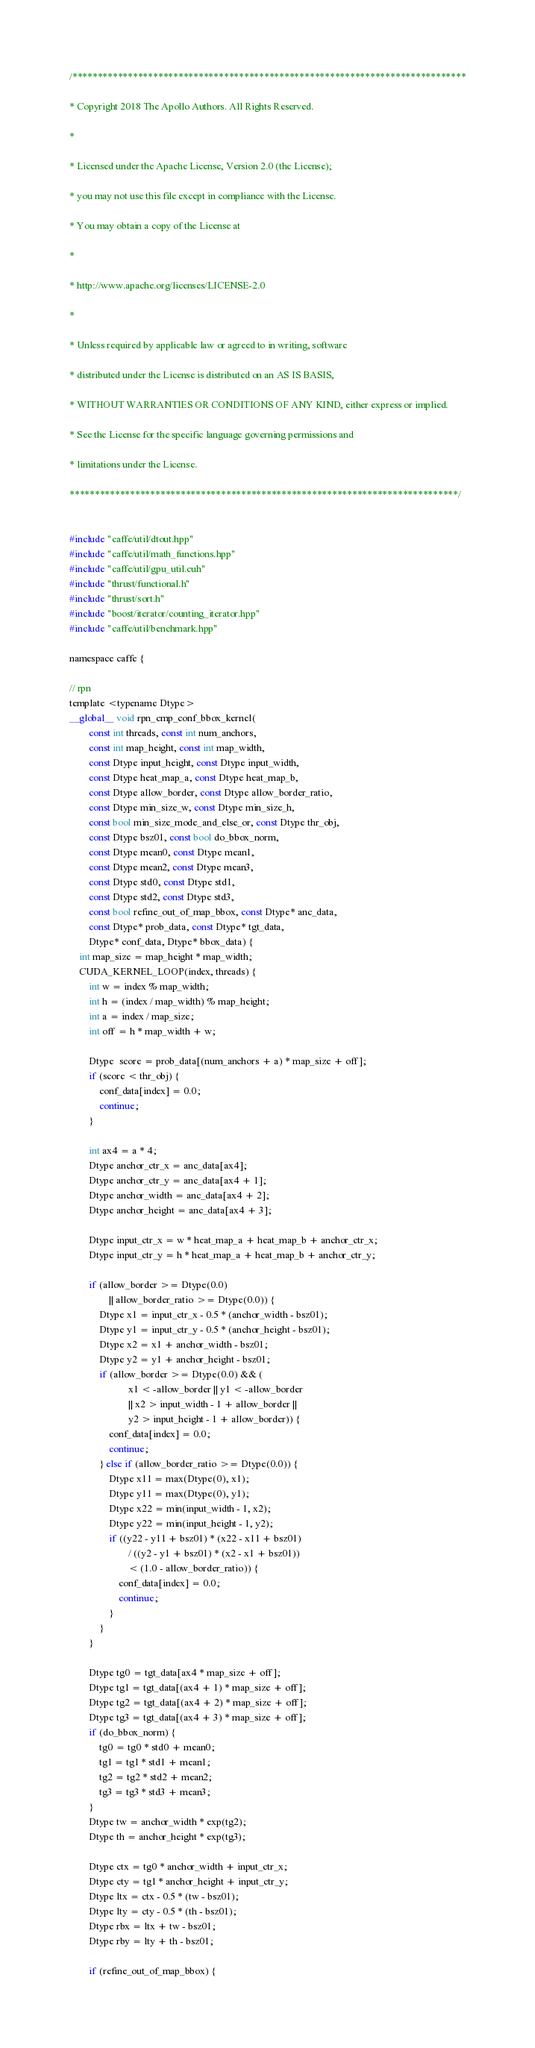Convert code to text. <code><loc_0><loc_0><loc_500><loc_500><_Cuda_>/******************************************************************************

* Copyright 2018 The Apollo Authors. All Rights Reserved.

*

* Licensed under the Apache License, Version 2.0 (the License);

* you may not use this file except in compliance with the License.

* You may obtain a copy of the License at

*

* http://www.apache.org/licenses/LICENSE-2.0

*

* Unless required by applicable law or agreed to in writing, software

* distributed under the License is distributed on an AS IS BASIS,

* WITHOUT WARRANTIES OR CONDITIONS OF ANY KIND, either express or implied.

* See the License for the specific language governing permissions and

* limitations under the License.

*****************************************************************************/


#include "caffe/util/dtout.hpp"
#include "caffe/util/math_functions.hpp"
#include "caffe/util/gpu_util.cuh"
#include "thrust/functional.h"
#include "thrust/sort.h"
#include "boost/iterator/counting_iterator.hpp"
#include "caffe/util/benchmark.hpp"

namespace caffe {

// rpn
template <typename Dtype>
__global__ void rpn_cmp_conf_bbox_kernel(
        const int threads, const int num_anchors, 
        const int map_height, const int map_width,
        const Dtype input_height, const Dtype input_width,
        const Dtype heat_map_a, const Dtype heat_map_b,
        const Dtype allow_border, const Dtype allow_border_ratio,
        const Dtype min_size_w, const Dtype min_size_h,
        const bool min_size_mode_and_else_or, const Dtype thr_obj,  
        const Dtype bsz01, const bool do_bbox_norm,
        const Dtype mean0, const Dtype mean1, 
        const Dtype mean2, const Dtype mean3,
        const Dtype std0, const Dtype std1,
        const Dtype std2, const Dtype std3,
        const bool refine_out_of_map_bbox, const Dtype* anc_data, 
        const Dtype* prob_data, const Dtype* tgt_data, 
        Dtype* conf_data, Dtype* bbox_data) {
    int map_size = map_height * map_width;
    CUDA_KERNEL_LOOP(index, threads) {
        int w = index % map_width;
        int h = (index / map_width) % map_height;
        int a = index / map_size;
        int off = h * map_width + w;

        Dtype  score = prob_data[(num_anchors + a) * map_size + off];
        if (score < thr_obj) {
            conf_data[index] = 0.0;
            continue;
        }

        int ax4 = a * 4;
        Dtype anchor_ctr_x = anc_data[ax4];
        Dtype anchor_ctr_y = anc_data[ax4 + 1];
        Dtype anchor_width = anc_data[ax4 + 2];
        Dtype anchor_height = anc_data[ax4 + 3];

        Dtype input_ctr_x = w * heat_map_a + heat_map_b + anchor_ctr_x;
        Dtype input_ctr_y = h * heat_map_a + heat_map_b + anchor_ctr_y;

        if (allow_border >= Dtype(0.0) 
                || allow_border_ratio >= Dtype(0.0)) {
            Dtype x1 = input_ctr_x - 0.5 * (anchor_width - bsz01); 
            Dtype y1 = input_ctr_y - 0.5 * (anchor_height - bsz01); 
            Dtype x2 = x1 + anchor_width - bsz01; 
            Dtype y2 = y1 + anchor_height - bsz01; 
            if (allow_border >= Dtype(0.0) && (
                        x1 < -allow_border || y1 < -allow_border 
                        || x2 > input_width - 1 + allow_border ||  
                        y2 > input_height - 1 + allow_border)) {
                conf_data[index] = 0.0;
                continue;
            } else if (allow_border_ratio >= Dtype(0.0)) {
                Dtype x11 = max(Dtype(0), x1);
                Dtype y11 = max(Dtype(0), y1);
                Dtype x22 = min(input_width - 1, x2);
                Dtype y22 = min(input_height - 1, y2);
                if ((y22 - y11 + bsz01) * (x22 - x11 + bsz01) 
                        / ((y2 - y1 + bsz01) * (x2 - x1 + bsz01)) 
                        < (1.0 - allow_border_ratio)) {
                    conf_data[index] = 0.0;
                    continue;
                }   
            }   
        }

        Dtype tg0 = tgt_data[ax4 * map_size + off];
        Dtype tg1 = tgt_data[(ax4 + 1) * map_size + off];
        Dtype tg2 = tgt_data[(ax4 + 2) * map_size + off];
        Dtype tg3 = tgt_data[(ax4 + 3) * map_size + off];
        if (do_bbox_norm) {
            tg0 = tg0 * std0 + mean0;
            tg1 = tg1 * std1 + mean1;
            tg2 = tg2 * std2 + mean2;
            tg3 = tg3 * std3 + mean3;
        }
        Dtype tw = anchor_width * exp(tg2);
        Dtype th = anchor_height * exp(tg3);

        Dtype ctx = tg0 * anchor_width + input_ctr_x;
        Dtype cty = tg1 * anchor_height + input_ctr_y;
        Dtype ltx = ctx - 0.5 * (tw - bsz01);
        Dtype lty = cty - 0.5 * (th - bsz01);
        Dtype rbx = ltx + tw - bsz01;
        Dtype rby = lty + th - bsz01;

        if (refine_out_of_map_bbox) {</code> 